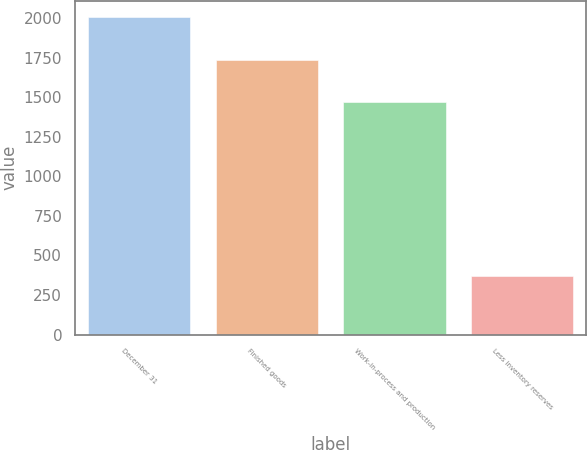Convert chart. <chart><loc_0><loc_0><loc_500><loc_500><bar_chart><fcel>December 31<fcel>Finished goods<fcel>Work-in-process and production<fcel>Less inventory reserves<nl><fcel>2007<fcel>1737<fcel>1470<fcel>371<nl></chart> 